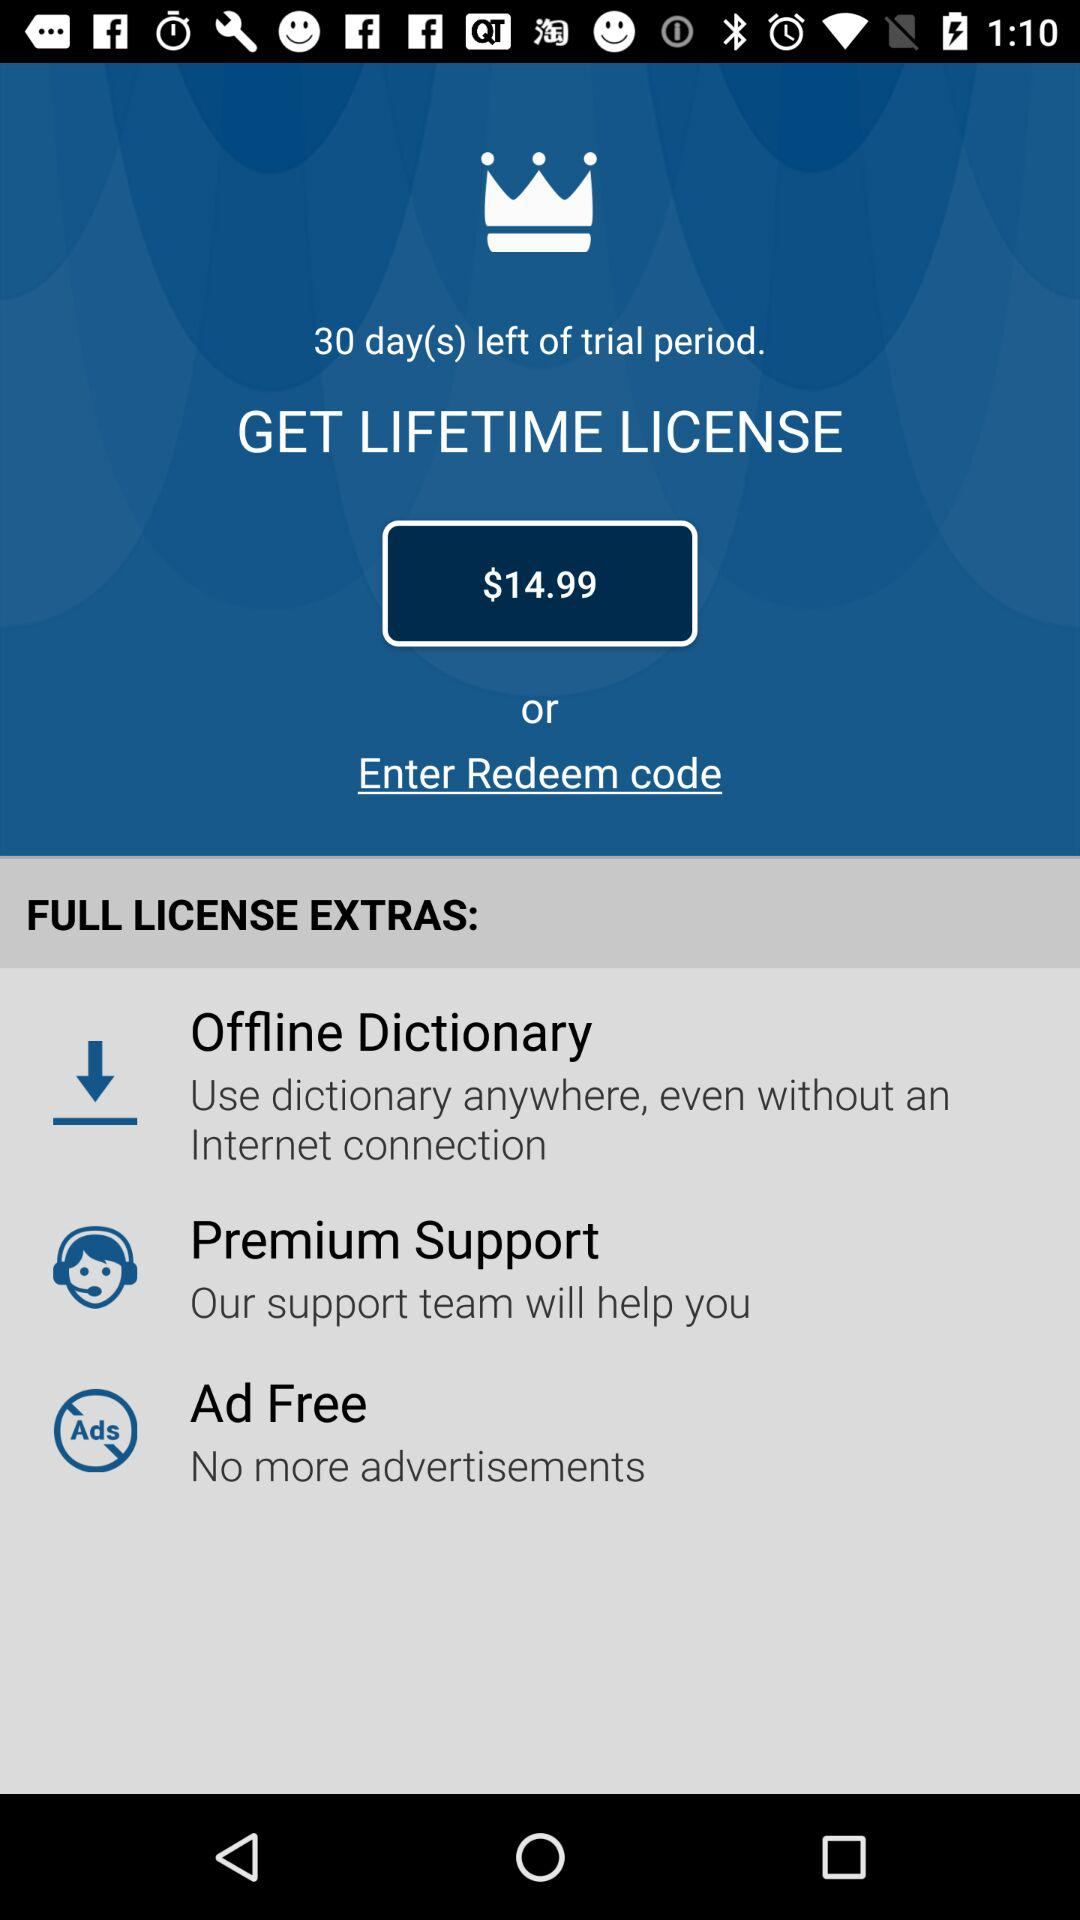What's the cost of the lifetime license? The cost is $14.99. 